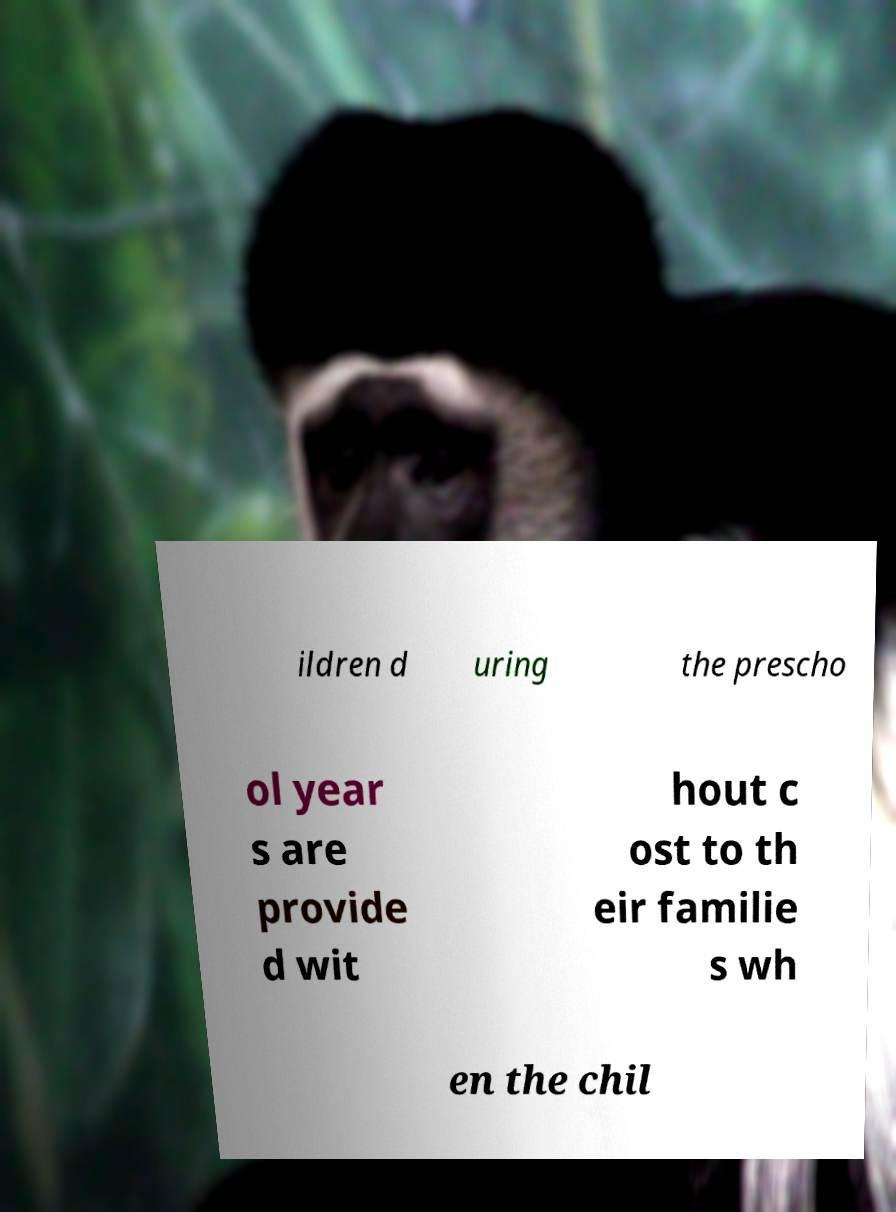Can you accurately transcribe the text from the provided image for me? ildren d uring the prescho ol year s are provide d wit hout c ost to th eir familie s wh en the chil 